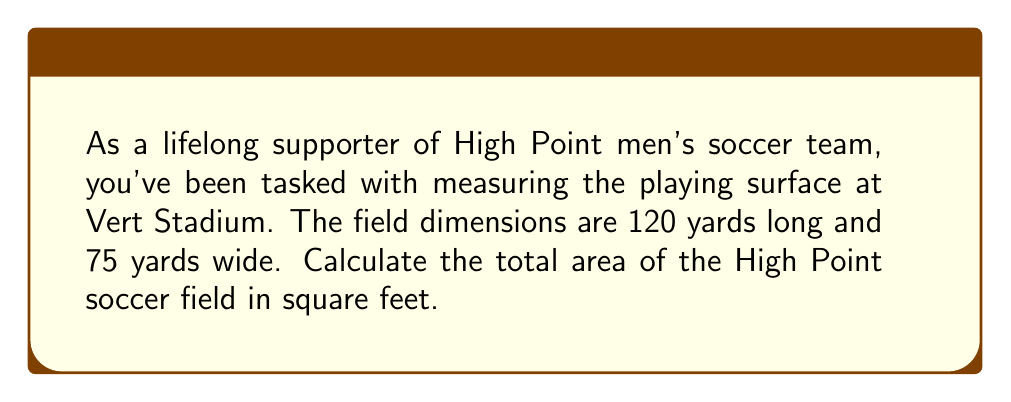Help me with this question. To solve this problem, we need to follow these steps:

1) First, we need to convert the dimensions from yards to feet:
   $$ 1 \text{ yard} = 3 \text{ feet} $$
   
   Length: $120 \text{ yards} \times 3 = 360 \text{ feet}$
   Width: $75 \text{ yards} \times 3 = 225 \text{ feet}$

2) Now that we have the dimensions in feet, we can calculate the area using the formula for the area of a rectangle:
   $$ A = l \times w $$
   Where $A$ is the area, $l$ is the length, and $w$ is the width.

3) Substituting our values:
   $$ A = 360 \text{ feet} \times 225 \text{ feet} $$

4) Multiplying:
   $$ A = 81,000 \text{ square feet} $$

[asy]
size(200);
draw((0,0)--(120,0)--(120,75)--(0,75)--cycle);
label("120 yards", (60,0), S);
label("75 yards", (0,37.5), W);
[/asy]

Therefore, the total area of the High Point soccer field is 81,000 square feet.
Answer: $81,000 \text{ square feet}$ 